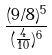Convert formula to latex. <formula><loc_0><loc_0><loc_500><loc_500>\frac { ( 9 / 8 ) ^ { 5 } } { ( \frac { 4 } { 1 0 } ) ^ { 6 } }</formula> 